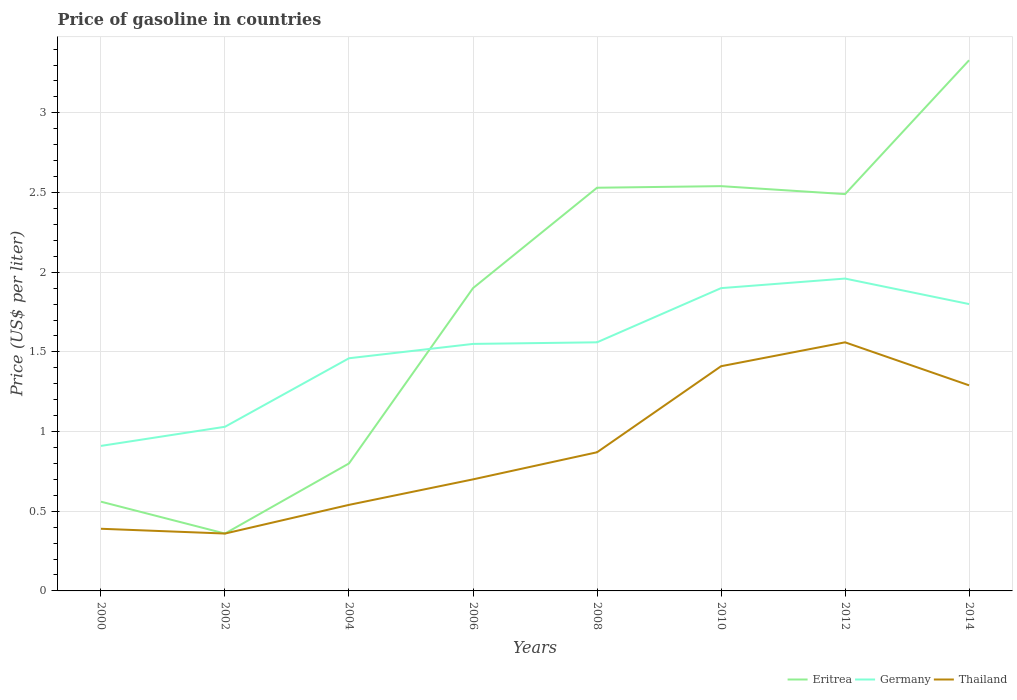How many different coloured lines are there?
Keep it short and to the point. 3. Across all years, what is the maximum price of gasoline in Eritrea?
Your answer should be very brief. 0.36. In which year was the price of gasoline in Eritrea maximum?
Offer a very short reply. 2002. What is the total price of gasoline in Thailand in the graph?
Your answer should be very brief. -0.17. What is the difference between the highest and the second highest price of gasoline in Germany?
Offer a very short reply. 1.05. What is the difference between the highest and the lowest price of gasoline in Eritrea?
Give a very brief answer. 5. What is the difference between two consecutive major ticks on the Y-axis?
Offer a very short reply. 0.5. How many legend labels are there?
Make the answer very short. 3. What is the title of the graph?
Provide a short and direct response. Price of gasoline in countries. What is the label or title of the X-axis?
Your answer should be compact. Years. What is the label or title of the Y-axis?
Offer a very short reply. Price (US$ per liter). What is the Price (US$ per liter) of Eritrea in 2000?
Provide a short and direct response. 0.56. What is the Price (US$ per liter) in Germany in 2000?
Offer a very short reply. 0.91. What is the Price (US$ per liter) of Thailand in 2000?
Your answer should be compact. 0.39. What is the Price (US$ per liter) in Eritrea in 2002?
Give a very brief answer. 0.36. What is the Price (US$ per liter) in Thailand in 2002?
Provide a short and direct response. 0.36. What is the Price (US$ per liter) in Germany in 2004?
Ensure brevity in your answer.  1.46. What is the Price (US$ per liter) of Thailand in 2004?
Provide a short and direct response. 0.54. What is the Price (US$ per liter) in Eritrea in 2006?
Offer a terse response. 1.9. What is the Price (US$ per liter) of Germany in 2006?
Your response must be concise. 1.55. What is the Price (US$ per liter) of Eritrea in 2008?
Offer a very short reply. 2.53. What is the Price (US$ per liter) of Germany in 2008?
Provide a short and direct response. 1.56. What is the Price (US$ per liter) of Thailand in 2008?
Provide a succinct answer. 0.87. What is the Price (US$ per liter) of Eritrea in 2010?
Your answer should be compact. 2.54. What is the Price (US$ per liter) in Thailand in 2010?
Provide a short and direct response. 1.41. What is the Price (US$ per liter) of Eritrea in 2012?
Your response must be concise. 2.49. What is the Price (US$ per liter) of Germany in 2012?
Give a very brief answer. 1.96. What is the Price (US$ per liter) of Thailand in 2012?
Your response must be concise. 1.56. What is the Price (US$ per liter) of Eritrea in 2014?
Offer a very short reply. 3.33. What is the Price (US$ per liter) of Thailand in 2014?
Your answer should be compact. 1.29. Across all years, what is the maximum Price (US$ per liter) in Eritrea?
Give a very brief answer. 3.33. Across all years, what is the maximum Price (US$ per liter) in Germany?
Keep it short and to the point. 1.96. Across all years, what is the maximum Price (US$ per liter) of Thailand?
Provide a succinct answer. 1.56. Across all years, what is the minimum Price (US$ per liter) of Eritrea?
Make the answer very short. 0.36. Across all years, what is the minimum Price (US$ per liter) in Germany?
Provide a short and direct response. 0.91. Across all years, what is the minimum Price (US$ per liter) of Thailand?
Provide a succinct answer. 0.36. What is the total Price (US$ per liter) in Eritrea in the graph?
Keep it short and to the point. 14.51. What is the total Price (US$ per liter) of Germany in the graph?
Give a very brief answer. 12.17. What is the total Price (US$ per liter) in Thailand in the graph?
Offer a very short reply. 7.12. What is the difference between the Price (US$ per liter) of Germany in 2000 and that in 2002?
Keep it short and to the point. -0.12. What is the difference between the Price (US$ per liter) in Eritrea in 2000 and that in 2004?
Your response must be concise. -0.24. What is the difference between the Price (US$ per liter) in Germany in 2000 and that in 2004?
Keep it short and to the point. -0.55. What is the difference between the Price (US$ per liter) of Eritrea in 2000 and that in 2006?
Provide a short and direct response. -1.34. What is the difference between the Price (US$ per liter) of Germany in 2000 and that in 2006?
Make the answer very short. -0.64. What is the difference between the Price (US$ per liter) of Thailand in 2000 and that in 2006?
Offer a very short reply. -0.31. What is the difference between the Price (US$ per liter) of Eritrea in 2000 and that in 2008?
Provide a short and direct response. -1.97. What is the difference between the Price (US$ per liter) of Germany in 2000 and that in 2008?
Your answer should be compact. -0.65. What is the difference between the Price (US$ per liter) of Thailand in 2000 and that in 2008?
Ensure brevity in your answer.  -0.48. What is the difference between the Price (US$ per liter) in Eritrea in 2000 and that in 2010?
Ensure brevity in your answer.  -1.98. What is the difference between the Price (US$ per liter) of Germany in 2000 and that in 2010?
Offer a very short reply. -0.99. What is the difference between the Price (US$ per liter) in Thailand in 2000 and that in 2010?
Your response must be concise. -1.02. What is the difference between the Price (US$ per liter) in Eritrea in 2000 and that in 2012?
Make the answer very short. -1.93. What is the difference between the Price (US$ per liter) in Germany in 2000 and that in 2012?
Your answer should be compact. -1.05. What is the difference between the Price (US$ per liter) in Thailand in 2000 and that in 2012?
Provide a succinct answer. -1.17. What is the difference between the Price (US$ per liter) of Eritrea in 2000 and that in 2014?
Provide a succinct answer. -2.77. What is the difference between the Price (US$ per liter) of Germany in 2000 and that in 2014?
Offer a very short reply. -0.89. What is the difference between the Price (US$ per liter) of Eritrea in 2002 and that in 2004?
Make the answer very short. -0.44. What is the difference between the Price (US$ per liter) of Germany in 2002 and that in 2004?
Ensure brevity in your answer.  -0.43. What is the difference between the Price (US$ per liter) in Thailand in 2002 and that in 2004?
Provide a short and direct response. -0.18. What is the difference between the Price (US$ per liter) of Eritrea in 2002 and that in 2006?
Keep it short and to the point. -1.54. What is the difference between the Price (US$ per liter) in Germany in 2002 and that in 2006?
Make the answer very short. -0.52. What is the difference between the Price (US$ per liter) of Thailand in 2002 and that in 2006?
Provide a succinct answer. -0.34. What is the difference between the Price (US$ per liter) in Eritrea in 2002 and that in 2008?
Your answer should be compact. -2.17. What is the difference between the Price (US$ per liter) in Germany in 2002 and that in 2008?
Give a very brief answer. -0.53. What is the difference between the Price (US$ per liter) of Thailand in 2002 and that in 2008?
Offer a terse response. -0.51. What is the difference between the Price (US$ per liter) of Eritrea in 2002 and that in 2010?
Ensure brevity in your answer.  -2.18. What is the difference between the Price (US$ per liter) of Germany in 2002 and that in 2010?
Ensure brevity in your answer.  -0.87. What is the difference between the Price (US$ per liter) of Thailand in 2002 and that in 2010?
Make the answer very short. -1.05. What is the difference between the Price (US$ per liter) in Eritrea in 2002 and that in 2012?
Offer a very short reply. -2.13. What is the difference between the Price (US$ per liter) of Germany in 2002 and that in 2012?
Make the answer very short. -0.93. What is the difference between the Price (US$ per liter) in Eritrea in 2002 and that in 2014?
Give a very brief answer. -2.97. What is the difference between the Price (US$ per liter) in Germany in 2002 and that in 2014?
Ensure brevity in your answer.  -0.77. What is the difference between the Price (US$ per liter) of Thailand in 2002 and that in 2014?
Make the answer very short. -0.93. What is the difference between the Price (US$ per liter) of Eritrea in 2004 and that in 2006?
Your answer should be compact. -1.1. What is the difference between the Price (US$ per liter) of Germany in 2004 and that in 2006?
Make the answer very short. -0.09. What is the difference between the Price (US$ per liter) of Thailand in 2004 and that in 2006?
Make the answer very short. -0.16. What is the difference between the Price (US$ per liter) of Eritrea in 2004 and that in 2008?
Your answer should be compact. -1.73. What is the difference between the Price (US$ per liter) in Germany in 2004 and that in 2008?
Your answer should be very brief. -0.1. What is the difference between the Price (US$ per liter) of Thailand in 2004 and that in 2008?
Give a very brief answer. -0.33. What is the difference between the Price (US$ per liter) in Eritrea in 2004 and that in 2010?
Your answer should be very brief. -1.74. What is the difference between the Price (US$ per liter) of Germany in 2004 and that in 2010?
Offer a terse response. -0.44. What is the difference between the Price (US$ per liter) of Thailand in 2004 and that in 2010?
Give a very brief answer. -0.87. What is the difference between the Price (US$ per liter) in Eritrea in 2004 and that in 2012?
Ensure brevity in your answer.  -1.69. What is the difference between the Price (US$ per liter) in Germany in 2004 and that in 2012?
Your answer should be very brief. -0.5. What is the difference between the Price (US$ per liter) in Thailand in 2004 and that in 2012?
Your answer should be very brief. -1.02. What is the difference between the Price (US$ per liter) in Eritrea in 2004 and that in 2014?
Keep it short and to the point. -2.53. What is the difference between the Price (US$ per liter) in Germany in 2004 and that in 2014?
Offer a terse response. -0.34. What is the difference between the Price (US$ per liter) of Thailand in 2004 and that in 2014?
Give a very brief answer. -0.75. What is the difference between the Price (US$ per liter) of Eritrea in 2006 and that in 2008?
Give a very brief answer. -0.63. What is the difference between the Price (US$ per liter) in Germany in 2006 and that in 2008?
Give a very brief answer. -0.01. What is the difference between the Price (US$ per liter) of Thailand in 2006 and that in 2008?
Offer a terse response. -0.17. What is the difference between the Price (US$ per liter) in Eritrea in 2006 and that in 2010?
Your answer should be compact. -0.64. What is the difference between the Price (US$ per liter) in Germany in 2006 and that in 2010?
Make the answer very short. -0.35. What is the difference between the Price (US$ per liter) of Thailand in 2006 and that in 2010?
Keep it short and to the point. -0.71. What is the difference between the Price (US$ per liter) of Eritrea in 2006 and that in 2012?
Ensure brevity in your answer.  -0.59. What is the difference between the Price (US$ per liter) in Germany in 2006 and that in 2012?
Provide a succinct answer. -0.41. What is the difference between the Price (US$ per liter) of Thailand in 2006 and that in 2012?
Make the answer very short. -0.86. What is the difference between the Price (US$ per liter) of Eritrea in 2006 and that in 2014?
Provide a short and direct response. -1.43. What is the difference between the Price (US$ per liter) of Germany in 2006 and that in 2014?
Offer a terse response. -0.25. What is the difference between the Price (US$ per liter) of Thailand in 2006 and that in 2014?
Give a very brief answer. -0.59. What is the difference between the Price (US$ per liter) in Eritrea in 2008 and that in 2010?
Give a very brief answer. -0.01. What is the difference between the Price (US$ per liter) in Germany in 2008 and that in 2010?
Your response must be concise. -0.34. What is the difference between the Price (US$ per liter) in Thailand in 2008 and that in 2010?
Offer a terse response. -0.54. What is the difference between the Price (US$ per liter) of Eritrea in 2008 and that in 2012?
Provide a short and direct response. 0.04. What is the difference between the Price (US$ per liter) of Thailand in 2008 and that in 2012?
Ensure brevity in your answer.  -0.69. What is the difference between the Price (US$ per liter) of Eritrea in 2008 and that in 2014?
Give a very brief answer. -0.8. What is the difference between the Price (US$ per liter) in Germany in 2008 and that in 2014?
Your answer should be compact. -0.24. What is the difference between the Price (US$ per liter) of Thailand in 2008 and that in 2014?
Keep it short and to the point. -0.42. What is the difference between the Price (US$ per liter) of Eritrea in 2010 and that in 2012?
Make the answer very short. 0.05. What is the difference between the Price (US$ per liter) of Germany in 2010 and that in 2012?
Provide a short and direct response. -0.06. What is the difference between the Price (US$ per liter) of Thailand in 2010 and that in 2012?
Make the answer very short. -0.15. What is the difference between the Price (US$ per liter) of Eritrea in 2010 and that in 2014?
Give a very brief answer. -0.79. What is the difference between the Price (US$ per liter) of Germany in 2010 and that in 2014?
Your answer should be compact. 0.1. What is the difference between the Price (US$ per liter) of Thailand in 2010 and that in 2014?
Your response must be concise. 0.12. What is the difference between the Price (US$ per liter) in Eritrea in 2012 and that in 2014?
Your answer should be very brief. -0.84. What is the difference between the Price (US$ per liter) in Germany in 2012 and that in 2014?
Offer a terse response. 0.16. What is the difference between the Price (US$ per liter) in Thailand in 2012 and that in 2014?
Ensure brevity in your answer.  0.27. What is the difference between the Price (US$ per liter) of Eritrea in 2000 and the Price (US$ per liter) of Germany in 2002?
Ensure brevity in your answer.  -0.47. What is the difference between the Price (US$ per liter) of Germany in 2000 and the Price (US$ per liter) of Thailand in 2002?
Your answer should be very brief. 0.55. What is the difference between the Price (US$ per liter) in Germany in 2000 and the Price (US$ per liter) in Thailand in 2004?
Offer a terse response. 0.37. What is the difference between the Price (US$ per liter) in Eritrea in 2000 and the Price (US$ per liter) in Germany in 2006?
Your answer should be very brief. -0.99. What is the difference between the Price (US$ per liter) of Eritrea in 2000 and the Price (US$ per liter) of Thailand in 2006?
Provide a succinct answer. -0.14. What is the difference between the Price (US$ per liter) in Germany in 2000 and the Price (US$ per liter) in Thailand in 2006?
Ensure brevity in your answer.  0.21. What is the difference between the Price (US$ per liter) in Eritrea in 2000 and the Price (US$ per liter) in Germany in 2008?
Your answer should be compact. -1. What is the difference between the Price (US$ per liter) of Eritrea in 2000 and the Price (US$ per liter) of Thailand in 2008?
Provide a succinct answer. -0.31. What is the difference between the Price (US$ per liter) in Eritrea in 2000 and the Price (US$ per liter) in Germany in 2010?
Give a very brief answer. -1.34. What is the difference between the Price (US$ per liter) of Eritrea in 2000 and the Price (US$ per liter) of Thailand in 2010?
Offer a very short reply. -0.85. What is the difference between the Price (US$ per liter) in Germany in 2000 and the Price (US$ per liter) in Thailand in 2012?
Your answer should be compact. -0.65. What is the difference between the Price (US$ per liter) in Eritrea in 2000 and the Price (US$ per liter) in Germany in 2014?
Keep it short and to the point. -1.24. What is the difference between the Price (US$ per liter) of Eritrea in 2000 and the Price (US$ per liter) of Thailand in 2014?
Make the answer very short. -0.73. What is the difference between the Price (US$ per liter) of Germany in 2000 and the Price (US$ per liter) of Thailand in 2014?
Give a very brief answer. -0.38. What is the difference between the Price (US$ per liter) of Eritrea in 2002 and the Price (US$ per liter) of Thailand in 2004?
Your answer should be compact. -0.18. What is the difference between the Price (US$ per liter) of Germany in 2002 and the Price (US$ per liter) of Thailand in 2004?
Provide a short and direct response. 0.49. What is the difference between the Price (US$ per liter) in Eritrea in 2002 and the Price (US$ per liter) in Germany in 2006?
Offer a very short reply. -1.19. What is the difference between the Price (US$ per liter) of Eritrea in 2002 and the Price (US$ per liter) of Thailand in 2006?
Ensure brevity in your answer.  -0.34. What is the difference between the Price (US$ per liter) of Germany in 2002 and the Price (US$ per liter) of Thailand in 2006?
Offer a very short reply. 0.33. What is the difference between the Price (US$ per liter) in Eritrea in 2002 and the Price (US$ per liter) in Germany in 2008?
Offer a very short reply. -1.2. What is the difference between the Price (US$ per liter) in Eritrea in 2002 and the Price (US$ per liter) in Thailand in 2008?
Ensure brevity in your answer.  -0.51. What is the difference between the Price (US$ per liter) of Germany in 2002 and the Price (US$ per liter) of Thailand in 2008?
Provide a succinct answer. 0.16. What is the difference between the Price (US$ per liter) of Eritrea in 2002 and the Price (US$ per liter) of Germany in 2010?
Provide a short and direct response. -1.54. What is the difference between the Price (US$ per liter) in Eritrea in 2002 and the Price (US$ per liter) in Thailand in 2010?
Offer a very short reply. -1.05. What is the difference between the Price (US$ per liter) in Germany in 2002 and the Price (US$ per liter) in Thailand in 2010?
Provide a short and direct response. -0.38. What is the difference between the Price (US$ per liter) in Germany in 2002 and the Price (US$ per liter) in Thailand in 2012?
Make the answer very short. -0.53. What is the difference between the Price (US$ per liter) in Eritrea in 2002 and the Price (US$ per liter) in Germany in 2014?
Provide a short and direct response. -1.44. What is the difference between the Price (US$ per liter) in Eritrea in 2002 and the Price (US$ per liter) in Thailand in 2014?
Your answer should be very brief. -0.93. What is the difference between the Price (US$ per liter) in Germany in 2002 and the Price (US$ per liter) in Thailand in 2014?
Give a very brief answer. -0.26. What is the difference between the Price (US$ per liter) of Eritrea in 2004 and the Price (US$ per liter) of Germany in 2006?
Provide a short and direct response. -0.75. What is the difference between the Price (US$ per liter) of Eritrea in 2004 and the Price (US$ per liter) of Thailand in 2006?
Offer a terse response. 0.1. What is the difference between the Price (US$ per liter) in Germany in 2004 and the Price (US$ per liter) in Thailand in 2006?
Your response must be concise. 0.76. What is the difference between the Price (US$ per liter) of Eritrea in 2004 and the Price (US$ per liter) of Germany in 2008?
Provide a succinct answer. -0.76. What is the difference between the Price (US$ per liter) in Eritrea in 2004 and the Price (US$ per liter) in Thailand in 2008?
Provide a short and direct response. -0.07. What is the difference between the Price (US$ per liter) in Germany in 2004 and the Price (US$ per liter) in Thailand in 2008?
Make the answer very short. 0.59. What is the difference between the Price (US$ per liter) of Eritrea in 2004 and the Price (US$ per liter) of Thailand in 2010?
Your answer should be compact. -0.61. What is the difference between the Price (US$ per liter) in Eritrea in 2004 and the Price (US$ per liter) in Germany in 2012?
Offer a terse response. -1.16. What is the difference between the Price (US$ per liter) of Eritrea in 2004 and the Price (US$ per liter) of Thailand in 2012?
Your answer should be very brief. -0.76. What is the difference between the Price (US$ per liter) of Eritrea in 2004 and the Price (US$ per liter) of Germany in 2014?
Offer a very short reply. -1. What is the difference between the Price (US$ per liter) of Eritrea in 2004 and the Price (US$ per liter) of Thailand in 2014?
Offer a very short reply. -0.49. What is the difference between the Price (US$ per liter) in Germany in 2004 and the Price (US$ per liter) in Thailand in 2014?
Give a very brief answer. 0.17. What is the difference between the Price (US$ per liter) in Eritrea in 2006 and the Price (US$ per liter) in Germany in 2008?
Your answer should be very brief. 0.34. What is the difference between the Price (US$ per liter) of Eritrea in 2006 and the Price (US$ per liter) of Thailand in 2008?
Ensure brevity in your answer.  1.03. What is the difference between the Price (US$ per liter) in Germany in 2006 and the Price (US$ per liter) in Thailand in 2008?
Your answer should be very brief. 0.68. What is the difference between the Price (US$ per liter) of Eritrea in 2006 and the Price (US$ per liter) of Thailand in 2010?
Give a very brief answer. 0.49. What is the difference between the Price (US$ per liter) in Germany in 2006 and the Price (US$ per liter) in Thailand in 2010?
Keep it short and to the point. 0.14. What is the difference between the Price (US$ per liter) of Eritrea in 2006 and the Price (US$ per liter) of Germany in 2012?
Offer a terse response. -0.06. What is the difference between the Price (US$ per liter) of Eritrea in 2006 and the Price (US$ per liter) of Thailand in 2012?
Provide a succinct answer. 0.34. What is the difference between the Price (US$ per liter) in Germany in 2006 and the Price (US$ per liter) in Thailand in 2012?
Keep it short and to the point. -0.01. What is the difference between the Price (US$ per liter) of Eritrea in 2006 and the Price (US$ per liter) of Thailand in 2014?
Give a very brief answer. 0.61. What is the difference between the Price (US$ per liter) in Germany in 2006 and the Price (US$ per liter) in Thailand in 2014?
Ensure brevity in your answer.  0.26. What is the difference between the Price (US$ per liter) in Eritrea in 2008 and the Price (US$ per liter) in Germany in 2010?
Offer a terse response. 0.63. What is the difference between the Price (US$ per liter) in Eritrea in 2008 and the Price (US$ per liter) in Thailand in 2010?
Provide a succinct answer. 1.12. What is the difference between the Price (US$ per liter) of Eritrea in 2008 and the Price (US$ per liter) of Germany in 2012?
Make the answer very short. 0.57. What is the difference between the Price (US$ per liter) in Eritrea in 2008 and the Price (US$ per liter) in Germany in 2014?
Offer a very short reply. 0.73. What is the difference between the Price (US$ per liter) in Eritrea in 2008 and the Price (US$ per liter) in Thailand in 2014?
Keep it short and to the point. 1.24. What is the difference between the Price (US$ per liter) of Germany in 2008 and the Price (US$ per liter) of Thailand in 2014?
Keep it short and to the point. 0.27. What is the difference between the Price (US$ per liter) in Eritrea in 2010 and the Price (US$ per liter) in Germany in 2012?
Your answer should be very brief. 0.58. What is the difference between the Price (US$ per liter) of Germany in 2010 and the Price (US$ per liter) of Thailand in 2012?
Ensure brevity in your answer.  0.34. What is the difference between the Price (US$ per liter) in Eritrea in 2010 and the Price (US$ per liter) in Germany in 2014?
Make the answer very short. 0.74. What is the difference between the Price (US$ per liter) in Eritrea in 2010 and the Price (US$ per liter) in Thailand in 2014?
Give a very brief answer. 1.25. What is the difference between the Price (US$ per liter) of Germany in 2010 and the Price (US$ per liter) of Thailand in 2014?
Provide a succinct answer. 0.61. What is the difference between the Price (US$ per liter) in Eritrea in 2012 and the Price (US$ per liter) in Germany in 2014?
Keep it short and to the point. 0.69. What is the difference between the Price (US$ per liter) in Eritrea in 2012 and the Price (US$ per liter) in Thailand in 2014?
Your response must be concise. 1.2. What is the difference between the Price (US$ per liter) of Germany in 2012 and the Price (US$ per liter) of Thailand in 2014?
Your answer should be very brief. 0.67. What is the average Price (US$ per liter) in Eritrea per year?
Ensure brevity in your answer.  1.81. What is the average Price (US$ per liter) in Germany per year?
Offer a very short reply. 1.52. What is the average Price (US$ per liter) of Thailand per year?
Provide a succinct answer. 0.89. In the year 2000, what is the difference between the Price (US$ per liter) of Eritrea and Price (US$ per liter) of Germany?
Provide a succinct answer. -0.35. In the year 2000, what is the difference between the Price (US$ per liter) of Eritrea and Price (US$ per liter) of Thailand?
Offer a very short reply. 0.17. In the year 2000, what is the difference between the Price (US$ per liter) of Germany and Price (US$ per liter) of Thailand?
Your answer should be very brief. 0.52. In the year 2002, what is the difference between the Price (US$ per liter) in Eritrea and Price (US$ per liter) in Germany?
Make the answer very short. -0.67. In the year 2002, what is the difference between the Price (US$ per liter) of Eritrea and Price (US$ per liter) of Thailand?
Offer a very short reply. 0. In the year 2002, what is the difference between the Price (US$ per liter) in Germany and Price (US$ per liter) in Thailand?
Give a very brief answer. 0.67. In the year 2004, what is the difference between the Price (US$ per liter) in Eritrea and Price (US$ per liter) in Germany?
Provide a succinct answer. -0.66. In the year 2004, what is the difference between the Price (US$ per liter) of Eritrea and Price (US$ per liter) of Thailand?
Your response must be concise. 0.26. In the year 2004, what is the difference between the Price (US$ per liter) of Germany and Price (US$ per liter) of Thailand?
Give a very brief answer. 0.92. In the year 2006, what is the difference between the Price (US$ per liter) of Eritrea and Price (US$ per liter) of Thailand?
Make the answer very short. 1.2. In the year 2008, what is the difference between the Price (US$ per liter) in Eritrea and Price (US$ per liter) in Germany?
Provide a succinct answer. 0.97. In the year 2008, what is the difference between the Price (US$ per liter) of Eritrea and Price (US$ per liter) of Thailand?
Give a very brief answer. 1.66. In the year 2008, what is the difference between the Price (US$ per liter) of Germany and Price (US$ per liter) of Thailand?
Your answer should be compact. 0.69. In the year 2010, what is the difference between the Price (US$ per liter) of Eritrea and Price (US$ per liter) of Germany?
Provide a short and direct response. 0.64. In the year 2010, what is the difference between the Price (US$ per liter) of Eritrea and Price (US$ per liter) of Thailand?
Give a very brief answer. 1.13. In the year 2010, what is the difference between the Price (US$ per liter) of Germany and Price (US$ per liter) of Thailand?
Your response must be concise. 0.49. In the year 2012, what is the difference between the Price (US$ per liter) in Eritrea and Price (US$ per liter) in Germany?
Your response must be concise. 0.53. In the year 2012, what is the difference between the Price (US$ per liter) in Germany and Price (US$ per liter) in Thailand?
Offer a terse response. 0.4. In the year 2014, what is the difference between the Price (US$ per liter) in Eritrea and Price (US$ per liter) in Germany?
Make the answer very short. 1.53. In the year 2014, what is the difference between the Price (US$ per liter) of Eritrea and Price (US$ per liter) of Thailand?
Provide a short and direct response. 2.04. In the year 2014, what is the difference between the Price (US$ per liter) in Germany and Price (US$ per liter) in Thailand?
Provide a short and direct response. 0.51. What is the ratio of the Price (US$ per liter) in Eritrea in 2000 to that in 2002?
Offer a very short reply. 1.56. What is the ratio of the Price (US$ per liter) in Germany in 2000 to that in 2002?
Keep it short and to the point. 0.88. What is the ratio of the Price (US$ per liter) in Eritrea in 2000 to that in 2004?
Make the answer very short. 0.7. What is the ratio of the Price (US$ per liter) of Germany in 2000 to that in 2004?
Keep it short and to the point. 0.62. What is the ratio of the Price (US$ per liter) in Thailand in 2000 to that in 2004?
Provide a short and direct response. 0.72. What is the ratio of the Price (US$ per liter) of Eritrea in 2000 to that in 2006?
Provide a short and direct response. 0.29. What is the ratio of the Price (US$ per liter) of Germany in 2000 to that in 2006?
Ensure brevity in your answer.  0.59. What is the ratio of the Price (US$ per liter) of Thailand in 2000 to that in 2006?
Give a very brief answer. 0.56. What is the ratio of the Price (US$ per liter) in Eritrea in 2000 to that in 2008?
Give a very brief answer. 0.22. What is the ratio of the Price (US$ per liter) in Germany in 2000 to that in 2008?
Provide a short and direct response. 0.58. What is the ratio of the Price (US$ per liter) in Thailand in 2000 to that in 2008?
Your answer should be very brief. 0.45. What is the ratio of the Price (US$ per liter) in Eritrea in 2000 to that in 2010?
Offer a terse response. 0.22. What is the ratio of the Price (US$ per liter) of Germany in 2000 to that in 2010?
Offer a very short reply. 0.48. What is the ratio of the Price (US$ per liter) of Thailand in 2000 to that in 2010?
Your answer should be compact. 0.28. What is the ratio of the Price (US$ per liter) of Eritrea in 2000 to that in 2012?
Make the answer very short. 0.22. What is the ratio of the Price (US$ per liter) of Germany in 2000 to that in 2012?
Offer a terse response. 0.46. What is the ratio of the Price (US$ per liter) in Thailand in 2000 to that in 2012?
Offer a terse response. 0.25. What is the ratio of the Price (US$ per liter) of Eritrea in 2000 to that in 2014?
Keep it short and to the point. 0.17. What is the ratio of the Price (US$ per liter) of Germany in 2000 to that in 2014?
Provide a short and direct response. 0.51. What is the ratio of the Price (US$ per liter) in Thailand in 2000 to that in 2014?
Make the answer very short. 0.3. What is the ratio of the Price (US$ per liter) in Eritrea in 2002 to that in 2004?
Your response must be concise. 0.45. What is the ratio of the Price (US$ per liter) of Germany in 2002 to that in 2004?
Your response must be concise. 0.71. What is the ratio of the Price (US$ per liter) of Thailand in 2002 to that in 2004?
Provide a short and direct response. 0.67. What is the ratio of the Price (US$ per liter) of Eritrea in 2002 to that in 2006?
Give a very brief answer. 0.19. What is the ratio of the Price (US$ per liter) of Germany in 2002 to that in 2006?
Offer a very short reply. 0.66. What is the ratio of the Price (US$ per liter) of Thailand in 2002 to that in 2006?
Give a very brief answer. 0.51. What is the ratio of the Price (US$ per liter) in Eritrea in 2002 to that in 2008?
Ensure brevity in your answer.  0.14. What is the ratio of the Price (US$ per liter) in Germany in 2002 to that in 2008?
Provide a short and direct response. 0.66. What is the ratio of the Price (US$ per liter) of Thailand in 2002 to that in 2008?
Offer a terse response. 0.41. What is the ratio of the Price (US$ per liter) in Eritrea in 2002 to that in 2010?
Make the answer very short. 0.14. What is the ratio of the Price (US$ per liter) of Germany in 2002 to that in 2010?
Make the answer very short. 0.54. What is the ratio of the Price (US$ per liter) in Thailand in 2002 to that in 2010?
Your answer should be compact. 0.26. What is the ratio of the Price (US$ per liter) of Eritrea in 2002 to that in 2012?
Make the answer very short. 0.14. What is the ratio of the Price (US$ per liter) in Germany in 2002 to that in 2012?
Offer a very short reply. 0.53. What is the ratio of the Price (US$ per liter) in Thailand in 2002 to that in 2012?
Give a very brief answer. 0.23. What is the ratio of the Price (US$ per liter) of Eritrea in 2002 to that in 2014?
Provide a succinct answer. 0.11. What is the ratio of the Price (US$ per liter) of Germany in 2002 to that in 2014?
Your response must be concise. 0.57. What is the ratio of the Price (US$ per liter) of Thailand in 2002 to that in 2014?
Give a very brief answer. 0.28. What is the ratio of the Price (US$ per liter) in Eritrea in 2004 to that in 2006?
Provide a succinct answer. 0.42. What is the ratio of the Price (US$ per liter) of Germany in 2004 to that in 2006?
Provide a succinct answer. 0.94. What is the ratio of the Price (US$ per liter) in Thailand in 2004 to that in 2006?
Your answer should be compact. 0.77. What is the ratio of the Price (US$ per liter) of Eritrea in 2004 to that in 2008?
Keep it short and to the point. 0.32. What is the ratio of the Price (US$ per liter) of Germany in 2004 to that in 2008?
Give a very brief answer. 0.94. What is the ratio of the Price (US$ per liter) of Thailand in 2004 to that in 2008?
Your answer should be very brief. 0.62. What is the ratio of the Price (US$ per liter) in Eritrea in 2004 to that in 2010?
Give a very brief answer. 0.32. What is the ratio of the Price (US$ per liter) in Germany in 2004 to that in 2010?
Give a very brief answer. 0.77. What is the ratio of the Price (US$ per liter) of Thailand in 2004 to that in 2010?
Provide a short and direct response. 0.38. What is the ratio of the Price (US$ per liter) of Eritrea in 2004 to that in 2012?
Your answer should be compact. 0.32. What is the ratio of the Price (US$ per liter) of Germany in 2004 to that in 2012?
Make the answer very short. 0.74. What is the ratio of the Price (US$ per liter) of Thailand in 2004 to that in 2012?
Offer a very short reply. 0.35. What is the ratio of the Price (US$ per liter) of Eritrea in 2004 to that in 2014?
Ensure brevity in your answer.  0.24. What is the ratio of the Price (US$ per liter) of Germany in 2004 to that in 2014?
Make the answer very short. 0.81. What is the ratio of the Price (US$ per liter) of Thailand in 2004 to that in 2014?
Your response must be concise. 0.42. What is the ratio of the Price (US$ per liter) of Eritrea in 2006 to that in 2008?
Your response must be concise. 0.75. What is the ratio of the Price (US$ per liter) in Germany in 2006 to that in 2008?
Keep it short and to the point. 0.99. What is the ratio of the Price (US$ per liter) of Thailand in 2006 to that in 2008?
Your answer should be compact. 0.8. What is the ratio of the Price (US$ per liter) in Eritrea in 2006 to that in 2010?
Provide a succinct answer. 0.75. What is the ratio of the Price (US$ per liter) of Germany in 2006 to that in 2010?
Ensure brevity in your answer.  0.82. What is the ratio of the Price (US$ per liter) in Thailand in 2006 to that in 2010?
Your answer should be compact. 0.5. What is the ratio of the Price (US$ per liter) of Eritrea in 2006 to that in 2012?
Ensure brevity in your answer.  0.76. What is the ratio of the Price (US$ per liter) in Germany in 2006 to that in 2012?
Your answer should be compact. 0.79. What is the ratio of the Price (US$ per liter) of Thailand in 2006 to that in 2012?
Provide a short and direct response. 0.45. What is the ratio of the Price (US$ per liter) of Eritrea in 2006 to that in 2014?
Make the answer very short. 0.57. What is the ratio of the Price (US$ per liter) of Germany in 2006 to that in 2014?
Your answer should be compact. 0.86. What is the ratio of the Price (US$ per liter) in Thailand in 2006 to that in 2014?
Provide a succinct answer. 0.54. What is the ratio of the Price (US$ per liter) of Eritrea in 2008 to that in 2010?
Make the answer very short. 1. What is the ratio of the Price (US$ per liter) in Germany in 2008 to that in 2010?
Offer a very short reply. 0.82. What is the ratio of the Price (US$ per liter) in Thailand in 2008 to that in 2010?
Keep it short and to the point. 0.62. What is the ratio of the Price (US$ per liter) in Eritrea in 2008 to that in 2012?
Offer a terse response. 1.02. What is the ratio of the Price (US$ per liter) in Germany in 2008 to that in 2012?
Keep it short and to the point. 0.8. What is the ratio of the Price (US$ per liter) in Thailand in 2008 to that in 2012?
Keep it short and to the point. 0.56. What is the ratio of the Price (US$ per liter) in Eritrea in 2008 to that in 2014?
Your response must be concise. 0.76. What is the ratio of the Price (US$ per liter) in Germany in 2008 to that in 2014?
Your response must be concise. 0.87. What is the ratio of the Price (US$ per liter) of Thailand in 2008 to that in 2014?
Offer a terse response. 0.67. What is the ratio of the Price (US$ per liter) of Eritrea in 2010 to that in 2012?
Offer a terse response. 1.02. What is the ratio of the Price (US$ per liter) of Germany in 2010 to that in 2012?
Offer a terse response. 0.97. What is the ratio of the Price (US$ per liter) of Thailand in 2010 to that in 2012?
Make the answer very short. 0.9. What is the ratio of the Price (US$ per liter) in Eritrea in 2010 to that in 2014?
Your response must be concise. 0.76. What is the ratio of the Price (US$ per liter) of Germany in 2010 to that in 2014?
Ensure brevity in your answer.  1.06. What is the ratio of the Price (US$ per liter) in Thailand in 2010 to that in 2014?
Provide a succinct answer. 1.09. What is the ratio of the Price (US$ per liter) of Eritrea in 2012 to that in 2014?
Make the answer very short. 0.75. What is the ratio of the Price (US$ per liter) in Germany in 2012 to that in 2014?
Provide a succinct answer. 1.09. What is the ratio of the Price (US$ per liter) of Thailand in 2012 to that in 2014?
Ensure brevity in your answer.  1.21. What is the difference between the highest and the second highest Price (US$ per liter) in Eritrea?
Your response must be concise. 0.79. What is the difference between the highest and the second highest Price (US$ per liter) in Germany?
Give a very brief answer. 0.06. What is the difference between the highest and the lowest Price (US$ per liter) in Eritrea?
Provide a short and direct response. 2.97. What is the difference between the highest and the lowest Price (US$ per liter) in Thailand?
Offer a terse response. 1.2. 